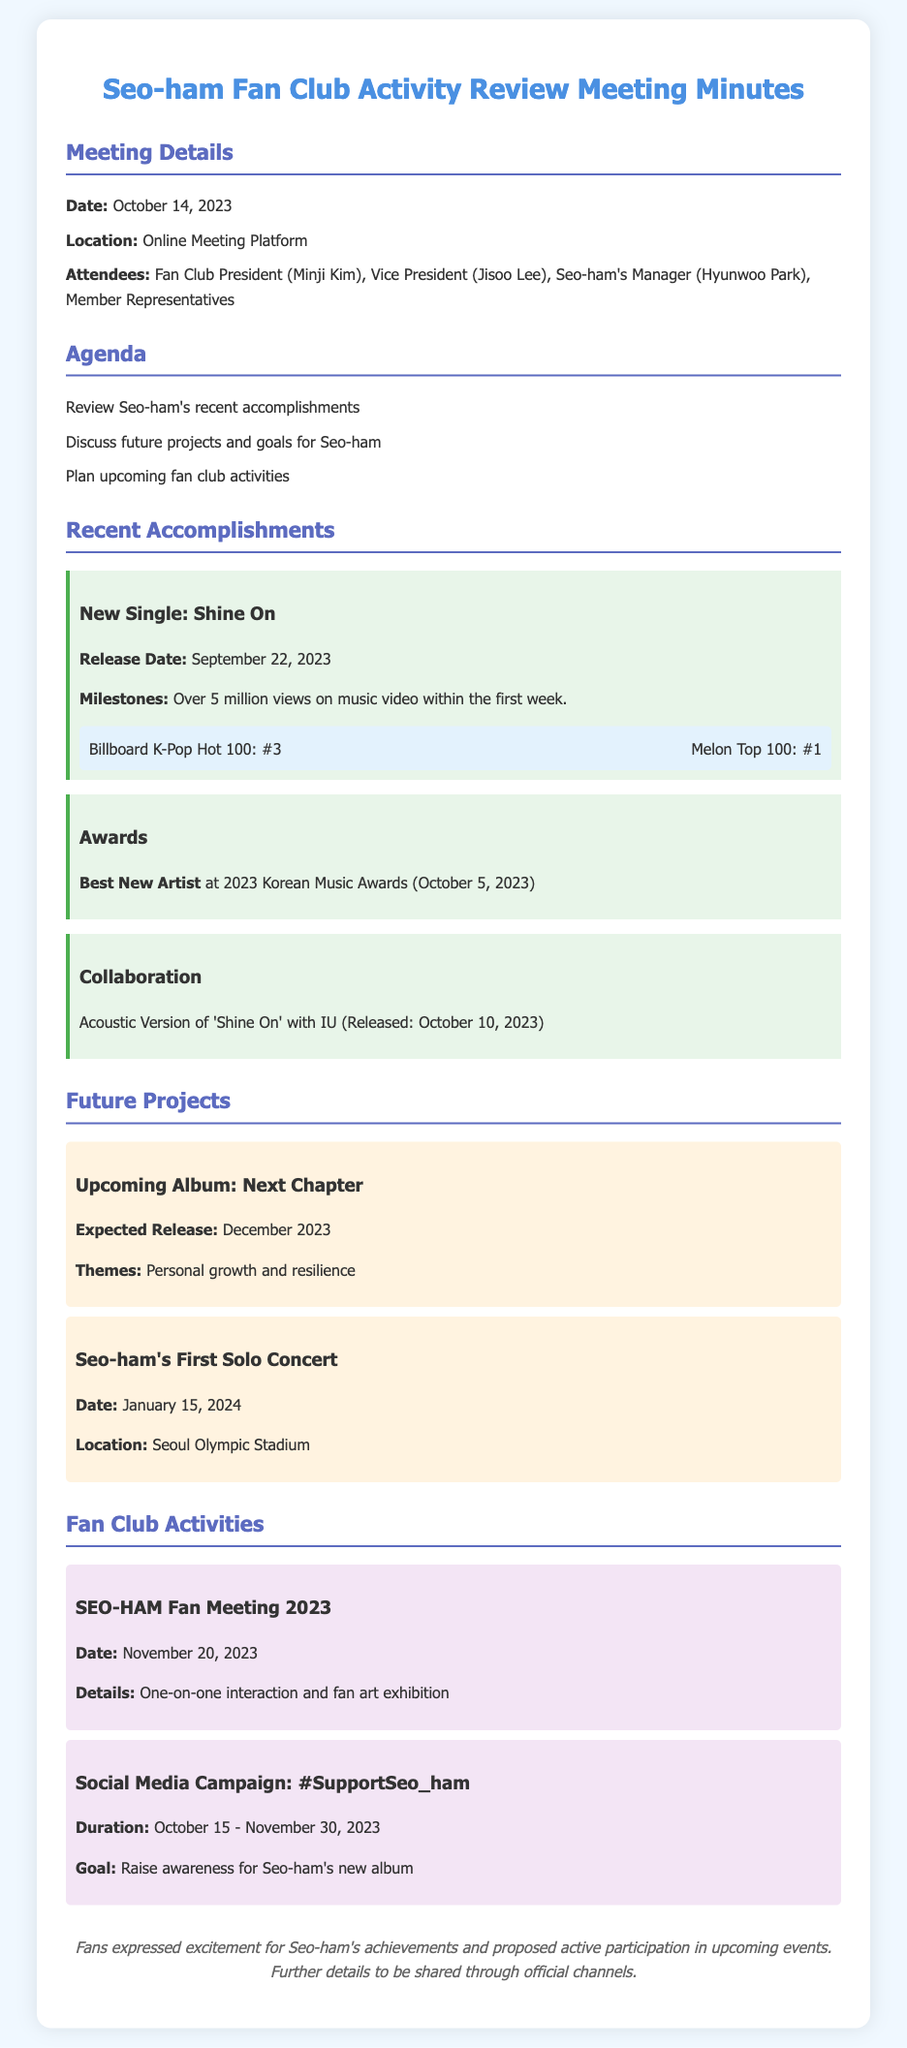What was the release date of Seo-ham's new single? The release date of Seo-ham's new single "Shine On" is mentioned in the document as September 22, 2023.
Answer: September 22, 2023 What was Seo-ham's ranking on the Melon Top 100? The document specifies that Seo-ham's ranking on the Melon Top 100 is #1.
Answer: #1 Which award did Seo-ham win at the 2023 Korean Music Awards? According to the minutes, Seo-ham won the "Best New Artist" award at the 2023 Korean Music Awards.
Answer: Best New Artist When is Seo-ham's first solo concert scheduled? The document indicates that Seo-ham's first solo concert is scheduled for January 15, 2024.
Answer: January 15, 2024 What is the theme of the upcoming album "Next Chapter"? The document mentions that the theme of the upcoming album is personal growth and resilience.
Answer: Personal growth and resilience What is the objective of the social media campaign #SupportSeo_ham? The campaign aims to raise awareness for Seo-ham's new album, as stated in the minutes.
Answer: Raise awareness for Seo-ham's new album How many views did the music video for "Shine On" achieve in the first week? The minutes highlight that "Shine On" gained over 5 million views on the music video within the first week.
Answer: Over 5 million views What kind of event is the SEO-HAM Fan Meeting 2023? The event details in the document specify it includes one-on-one interaction and a fan art exhibition.
Answer: One-on-one interaction and fan art exhibition What is the start date of the social media campaign? The start date of the campaign is provided in the document as October 15, 2023.
Answer: October 15, 2023 